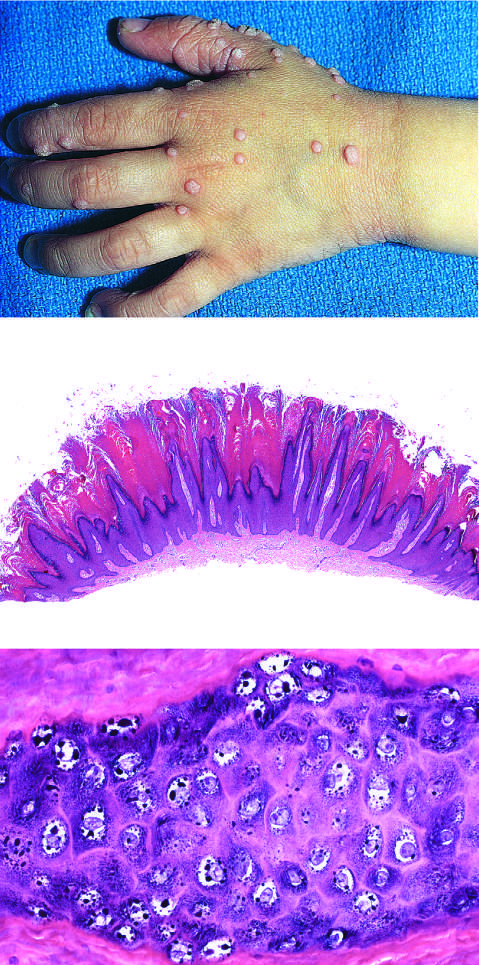does this specimen from a patient with periventricular leukomalacia contain zones of papillary epidermal proliferation that often radiate symmetrically like the points of a crown?
Answer the question using a single word or phrase. No 